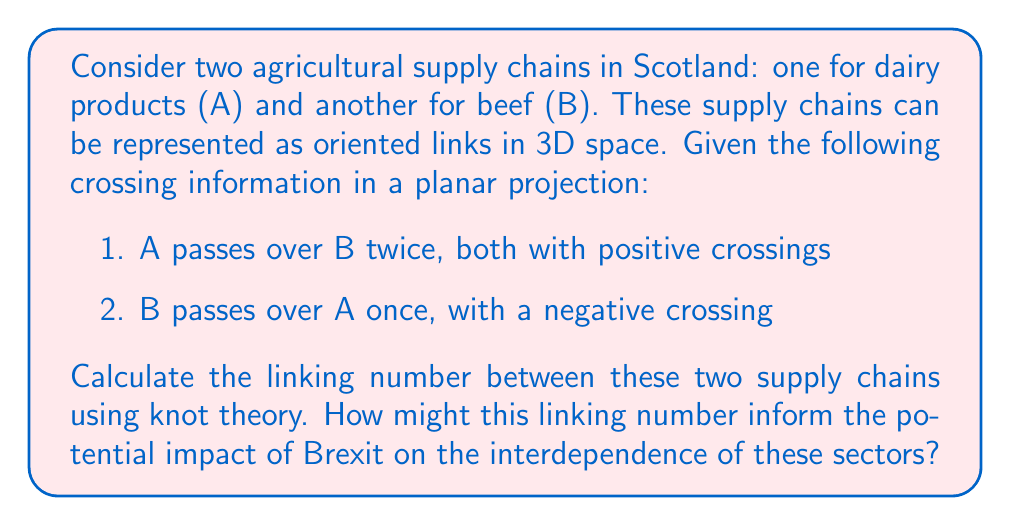Solve this math problem. To solve this problem, we'll use the concept of linking number from knot theory. The linking number is a topological invariant that measures how two curves are linked in three-dimensional space. For an economist studying Brexit's impact on Scottish agriculture, this can represent the interdependence of different agricultural sectors.

Step 1: Identify the crossings
We have three crossings in total:
- Two positive crossings where A passes over B
- One negative crossing where B passes over A

Step 2: Calculate the linking number
The linking number is calculated as half the sum of the crossing signs:

$$ Lk(A,B) = \frac{1}{2} \sum \text{sign}(c) $$

Where $c$ represents each crossing.

$$ Lk(A,B) = \frac{1}{2} (+1 + 1 - 1) = \frac{1}{2} $$

Step 3: Interpret the result
The linking number of 1/2 indicates that the two supply chains are linked and have some degree of interdependence. In the context of Brexit:

1. A non-zero linking number suggests that changes in trade policies affecting one sector (e.g., dairy) could impact the other (e.g., beef).
2. The positive value indicates a generally aligned relationship between the sectors.
3. The fractional value (1/2) implies a moderate level of interdependence, which could mean that while the sectors are connected, they may have some capacity to adapt independently to Brexit-related changes.

This analysis could help inform strategies for mitigating Brexit's impact on these interconnected agricultural sectors in Scotland.
Answer: $$Lk(A,B) = \frac{1}{2}$$ 